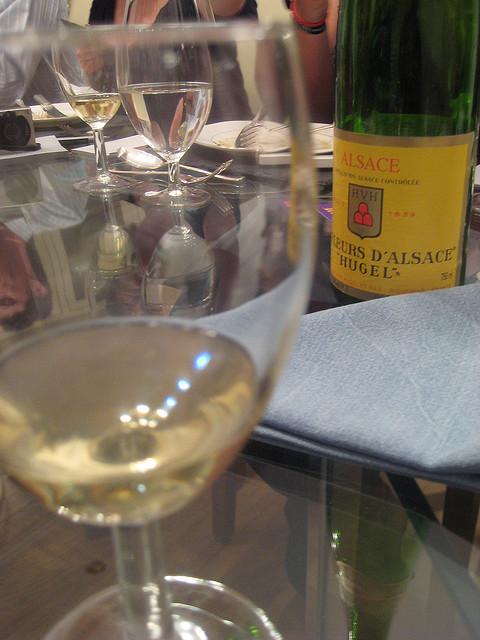What is the green object to the right?
Be succinct. Wine bottle. What is in the glass?
Give a very brief answer. Wine. Is there merlot in the image?
Give a very brief answer. No. How many wine glasses are on the table?
Keep it brief. 3. Where is the white wine bottle?
Keep it brief. On table. 